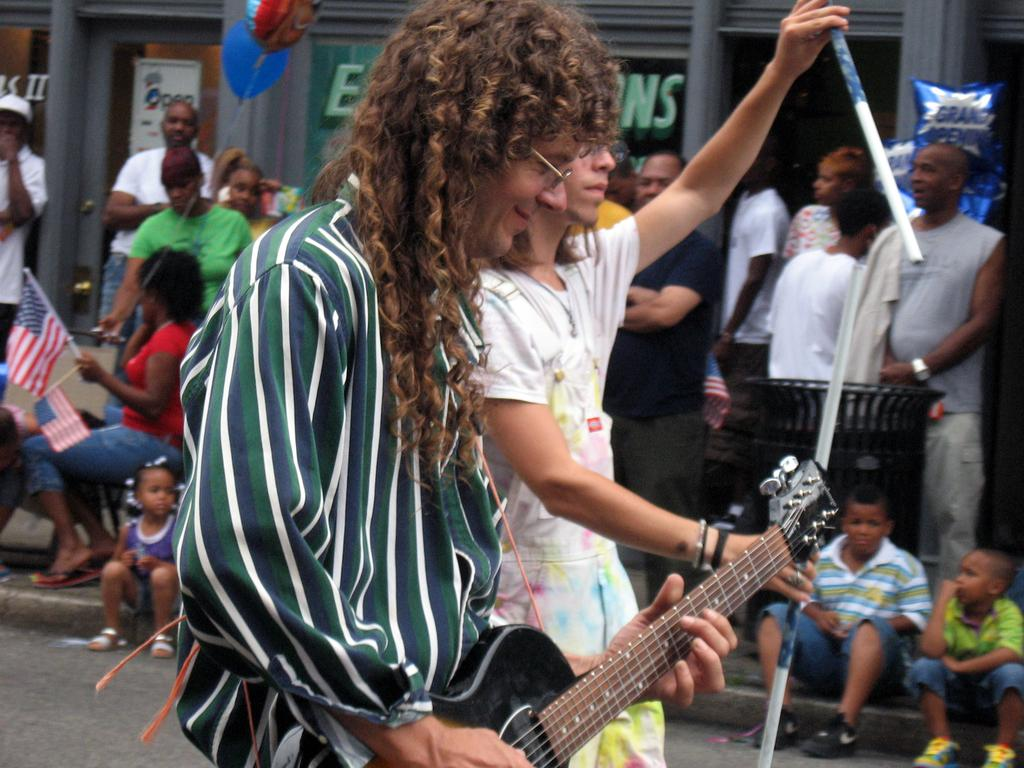What can be seen in the image involving people? There are people standing in the image. What additional object is present in the image? A balloon is present in the image. What is the man holding in the image? A man is holding a guitar in the image. What type of lace can be seen on the dress of the person in the image? There is no dress present in the image, and therefore no lace can be observed. 